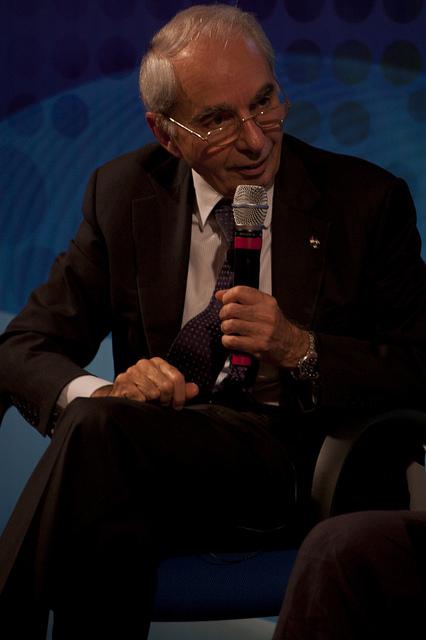Is this man married?
Short answer required. No. What is the person holding?
Answer briefly. Microphone. Is it likely this person checks  the time by using their smart phone?
Write a very short answer. No. What type of furniture is this person sitting on?
Be succinct. Chair. What type of flower is covering the man's face?
Short answer required. None. What arm is the man wearing a watch?
Write a very short answer. Left. 